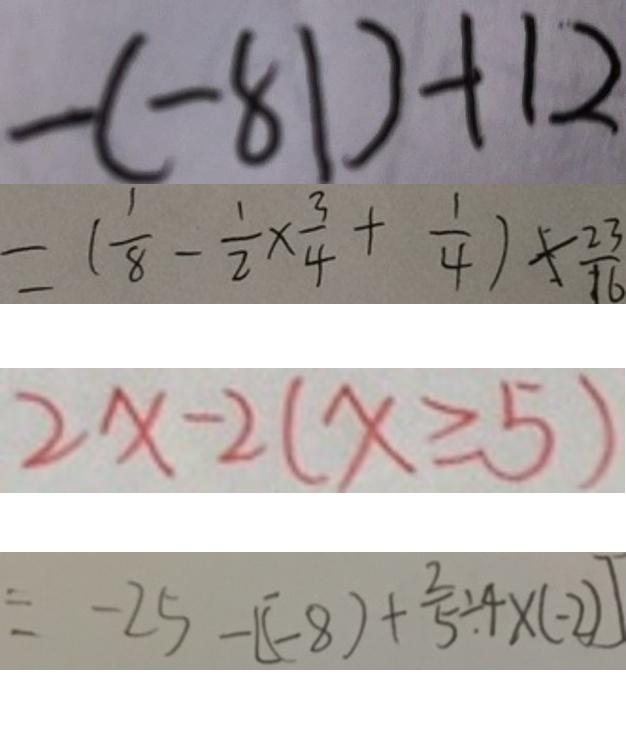Convert formula to latex. <formula><loc_0><loc_0><loc_500><loc_500>- ( - 8 1 ) + 1 2 
 = ( \frac { 1 } { 8 } - \frac { 1 } { 2 } \times \frac { 3 } { 4 } + \frac { 1 } { 4 } ) \times \frac { 2 3 } { 1 6 } 
 2 x - 2 ( x \geqslant 5 ) 
 = - 2 5 - [ ( - 8 ) + \frac { 2 } { 5 } \div 4 \times ( - 2 ) ]</formula> 